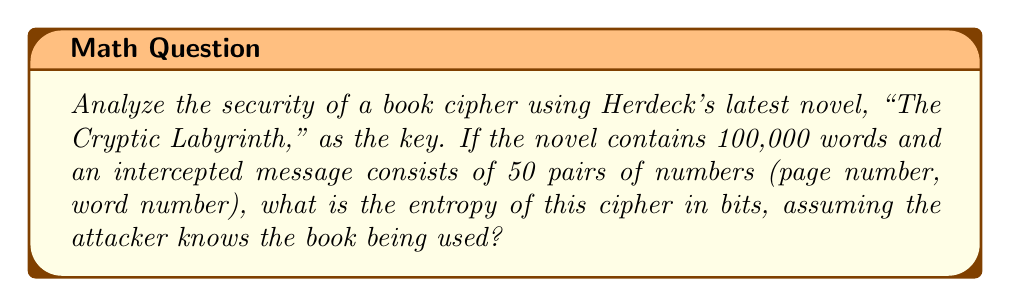Could you help me with this problem? To analyze the security of this book cipher, we need to calculate its entropy, which measures the amount of uncertainty in the system. Let's approach this step-by-step:

1) First, we need to determine the number of possible combinations for each pair of numbers:
   - The book has 100,000 words
   - Let's assume the book has approximately 250 pages (400 words per page on average)

2) For each pair (page number, word number), we have:
   - 250 possible page numbers
   - 400 possible word numbers per page

3) The total number of possibilities for each pair is:
   $$ 250 \times 400 = 100,000 $$

4) This matches the total word count, which makes sense as each word can be uniquely identified by its page and position.

5) For a message with 50 pairs, the total number of possible messages is:
   $$ (100,000)^{50} $$

6) The entropy in bits is calculated as the log base 2 of the number of possibilities:
   $$ H = \log_2((100,000)^{50}) $$

7) Using the properties of logarithms, this can be simplified to:
   $$ H = 50 \times \log_2(100,000) $$

8) $\log_2(100,000) \approx 16.61$ bits

9) Therefore, the total entropy is:
   $$ H \approx 50 \times 16.61 = 830.5 \text{ bits} $$

This high entropy indicates that the cipher is quite secure against brute-force attacks, even if the attacker knows which book is being used as the key.
Answer: 830.5 bits 